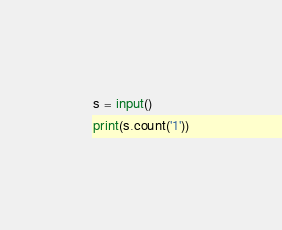<code> <loc_0><loc_0><loc_500><loc_500><_Python_>s = input()
print(s.count('1'))</code> 